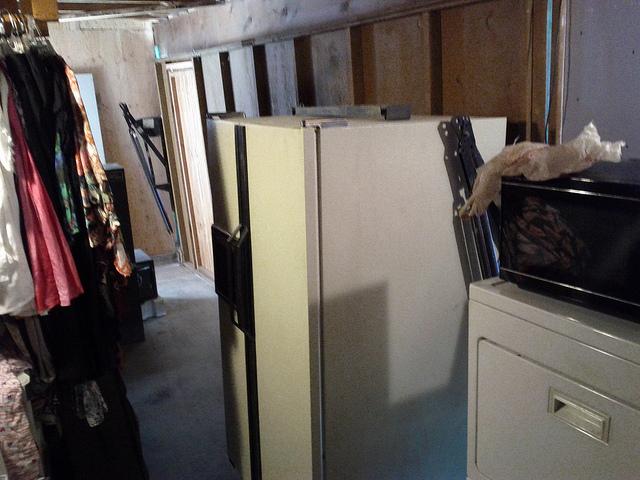Is this photo in the basement?
Keep it brief. Yes. Which side is the refrigerator handle?
Concise answer only. Both. What is to the right of the fridge?
Keep it brief. Microwave. 